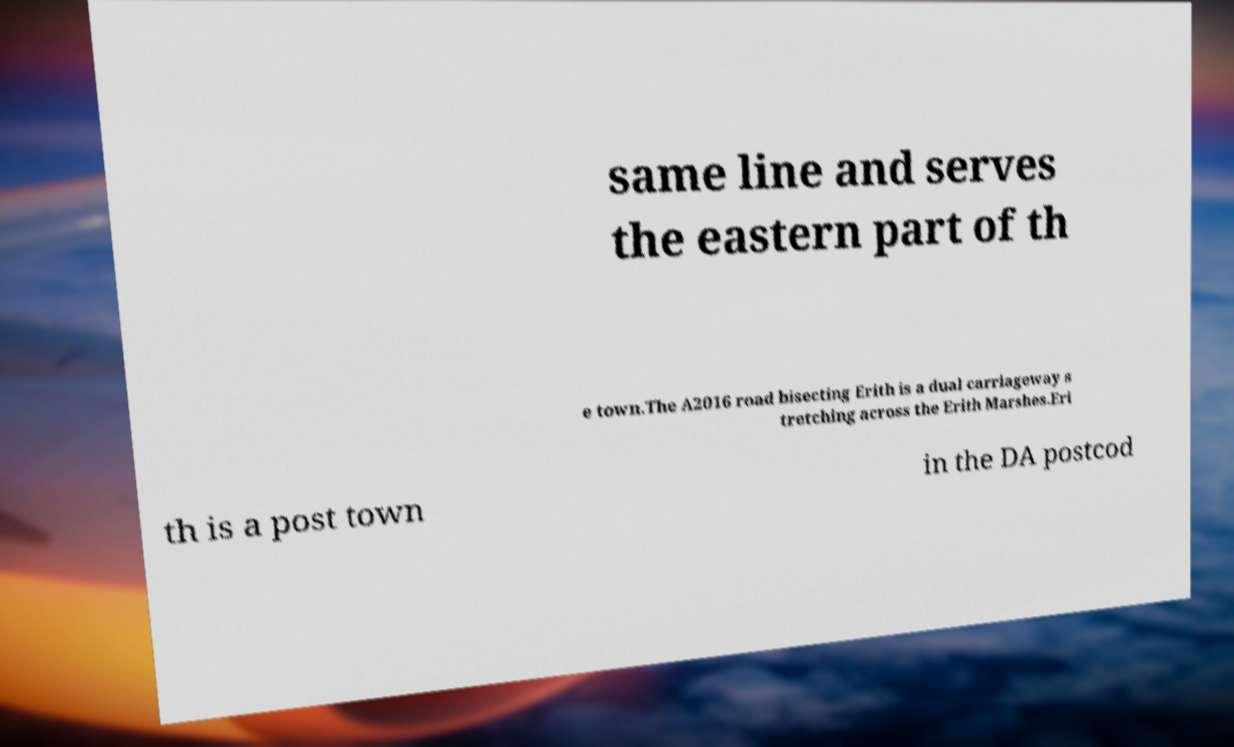There's text embedded in this image that I need extracted. Can you transcribe it verbatim? same line and serves the eastern part of th e town.The A2016 road bisecting Erith is a dual carriageway s tretching across the Erith Marshes.Eri th is a post town in the DA postcod 